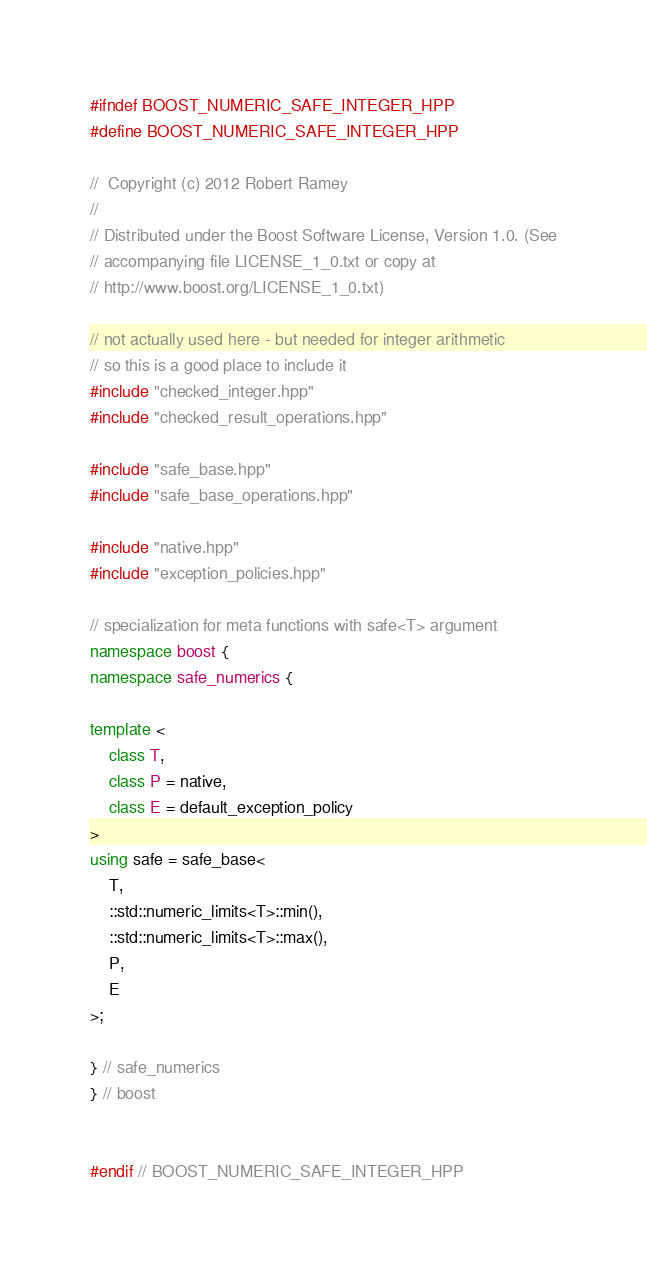Convert code to text. <code><loc_0><loc_0><loc_500><loc_500><_C++_>#ifndef BOOST_NUMERIC_SAFE_INTEGER_HPP
#define BOOST_NUMERIC_SAFE_INTEGER_HPP

//  Copyright (c) 2012 Robert Ramey
//
// Distributed under the Boost Software License, Version 1.0. (See
// accompanying file LICENSE_1_0.txt or copy at
// http://www.boost.org/LICENSE_1_0.txt)

// not actually used here - but needed for integer arithmetic
// so this is a good place to include it
#include "checked_integer.hpp"
#include "checked_result_operations.hpp"

#include "safe_base.hpp"
#include "safe_base_operations.hpp"

#include "native.hpp"
#include "exception_policies.hpp"

// specialization for meta functions with safe<T> argument
namespace boost {
namespace safe_numerics {

template <
    class T,
    class P = native,
    class E = default_exception_policy
>
using safe = safe_base<
    T,
    ::std::numeric_limits<T>::min(),
    ::std::numeric_limits<T>::max(),
    P,
    E
>;

} // safe_numerics
} // boost


#endif // BOOST_NUMERIC_SAFE_INTEGER_HPP
</code> 